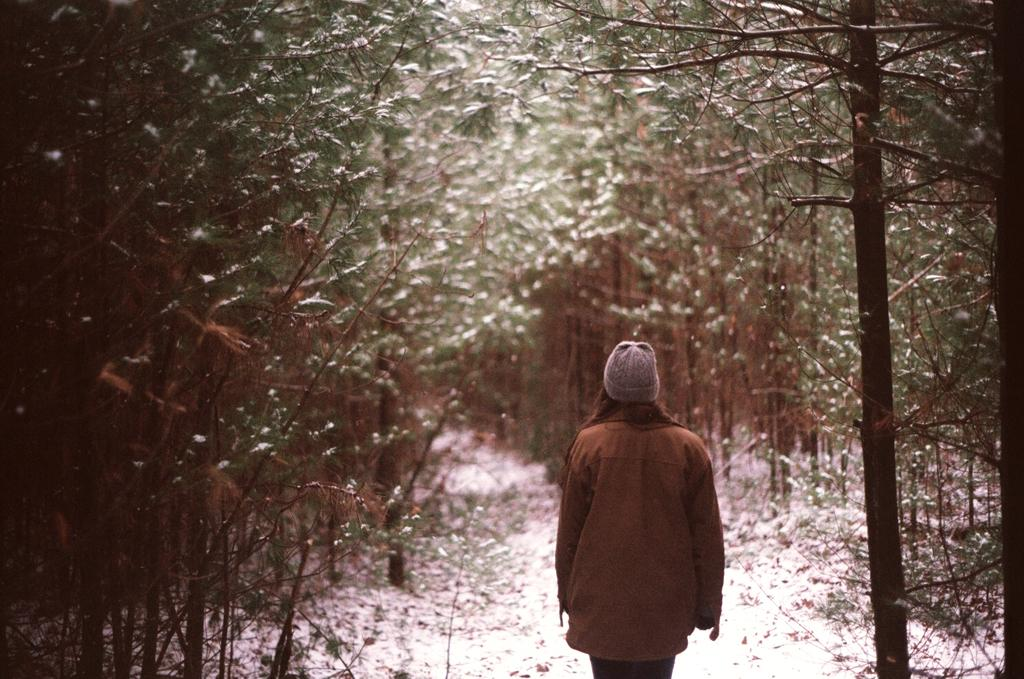Who is present in the image? There is a person in the image. What is the person wearing? The person is wearing a brown jacket. What is the person's posture in the image? The person is standing. What can be seen in the background of the image? There are trees visible in the background of the image. What is the ground made of in the image? There appears to be snow at the bottom of the image. How many men are visible on the floor in the image? There are no men visible on the floor in the image; it only features a person standing in a snowy environment. 